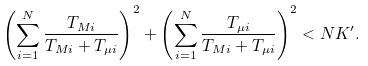Convert formula to latex. <formula><loc_0><loc_0><loc_500><loc_500>\left ( \sum _ { i = 1 } ^ { N } \frac { T _ { M i } } { T _ { M i } + T _ { \mu i } } \right ) ^ { 2 } + \left ( \sum _ { i = 1 } ^ { N } \frac { T _ { \mu i } } { T _ { M i } + T _ { \mu i } } \right ) ^ { 2 } < N K ^ { \prime } .</formula> 